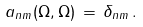Convert formula to latex. <formula><loc_0><loc_0><loc_500><loc_500>a _ { n m } ( \Omega , \Omega ) \, = \, \delta _ { n m } \, .</formula> 